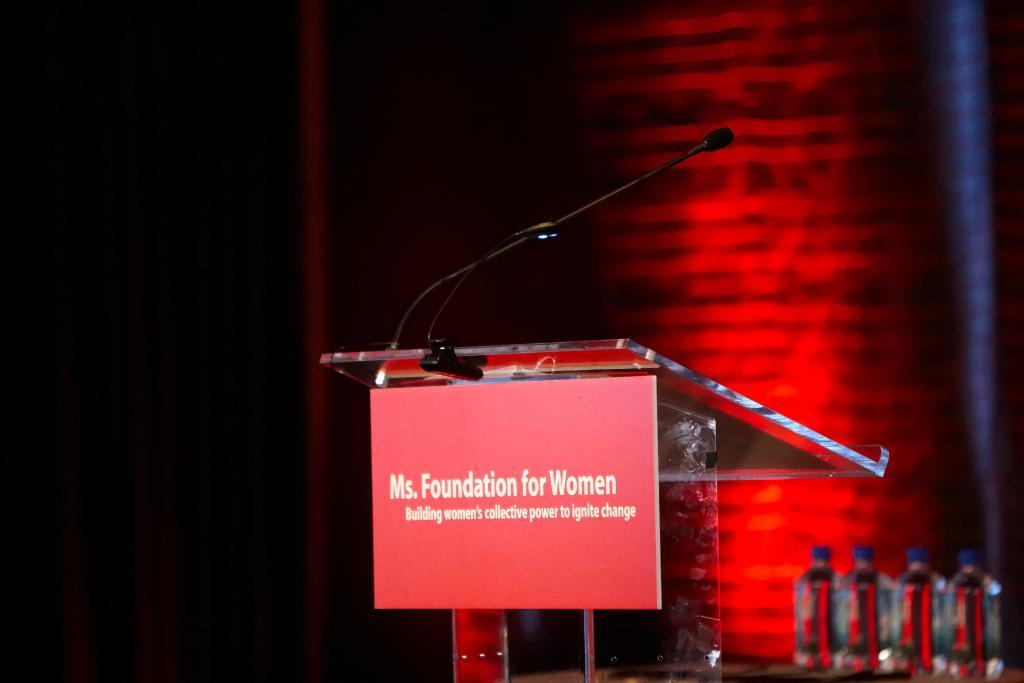What is the main object in the image? There is a microphone in the image. What other objects can be seen in the image? There is a red color board and water bottles in the image. How would you describe the background of the image? The background of the image is dark. How many geese are sitting on the floor in the image? There are no geese present in the image. What type of coil is wrapped around the microphone in the image? There is no coil wrapped around the microphone in the image. 